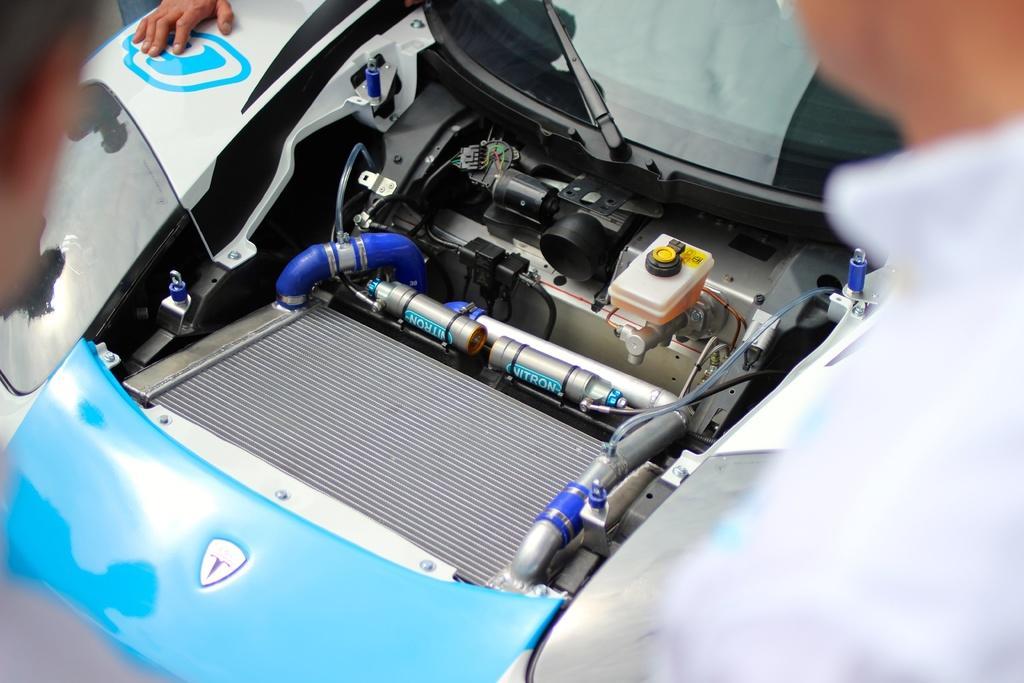Can you describe this image briefly? In this image there is a car truncated towards the top of the image, there is a person truncated towards the right of the image, there is a person truncated towards the left of the image, there is a person truncated towards the top of the image. 